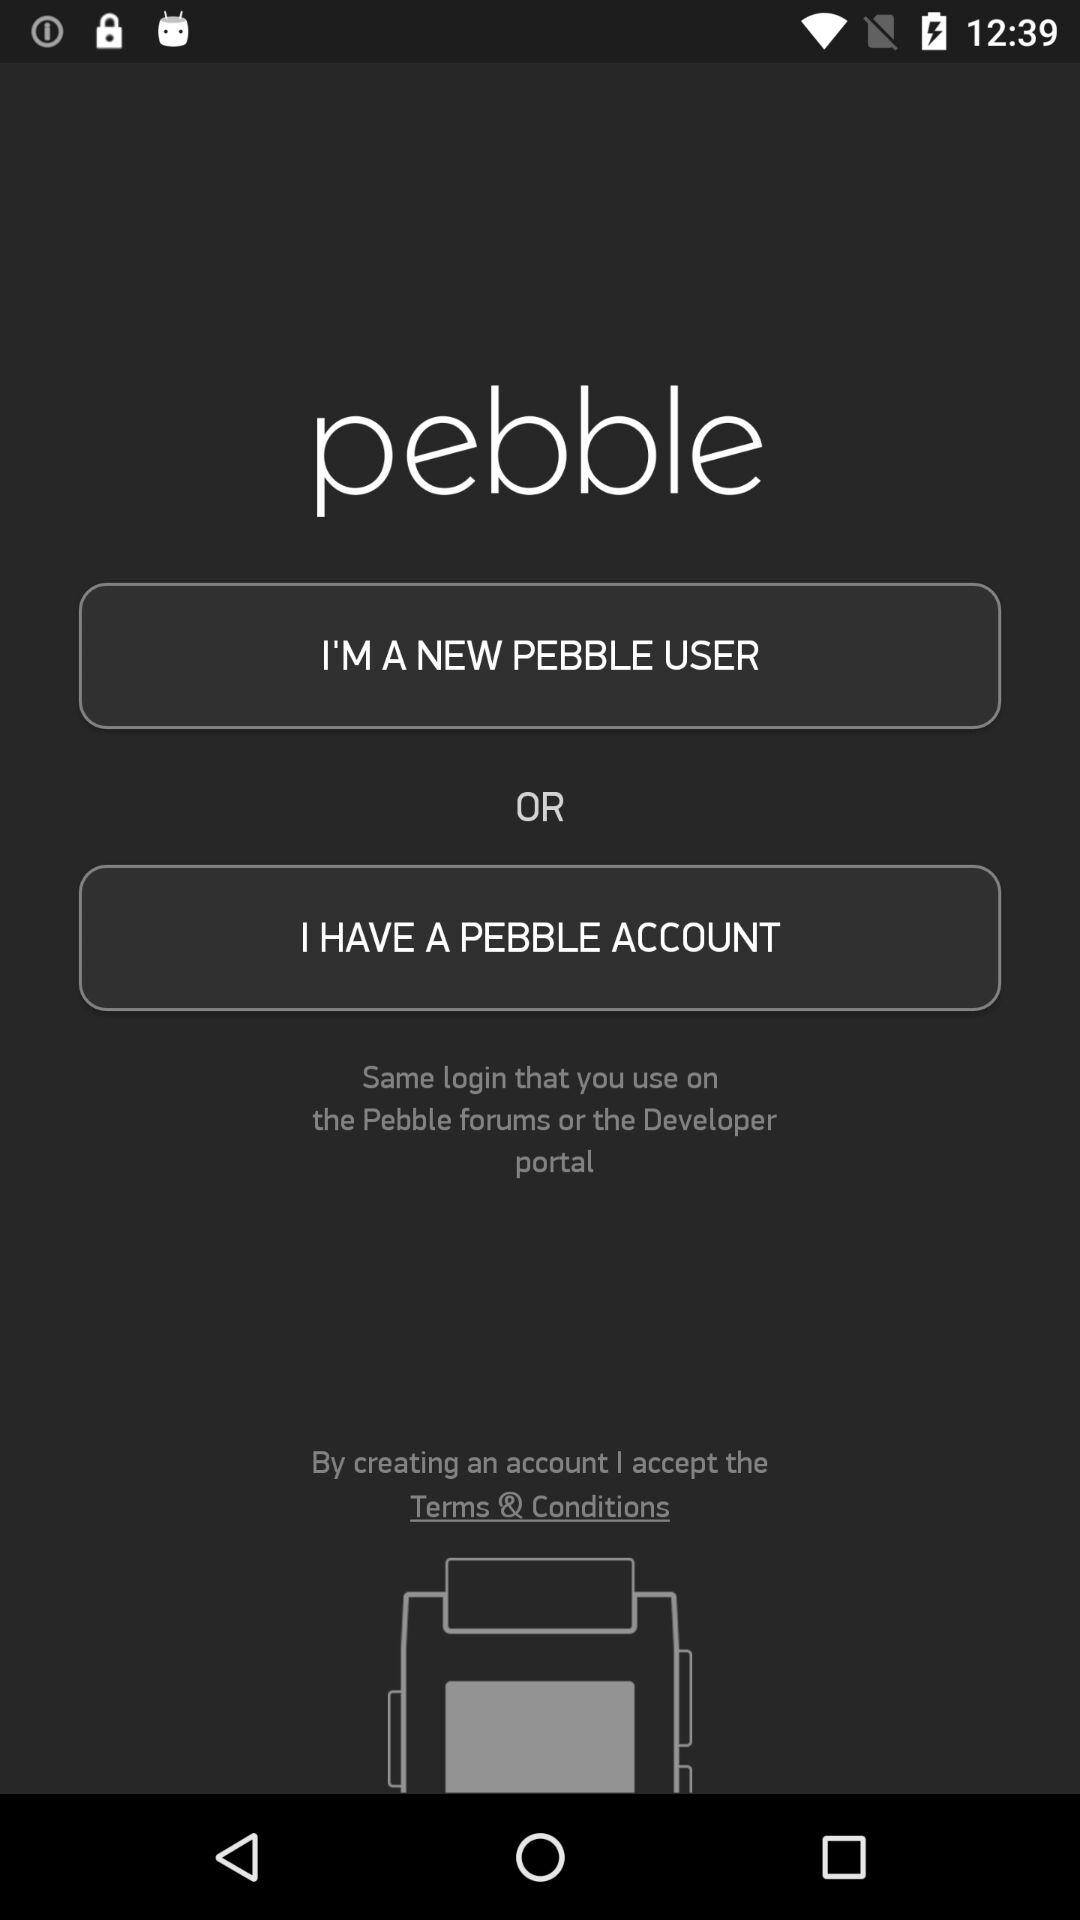What is the name of the application? The name of the application is "pebble". 